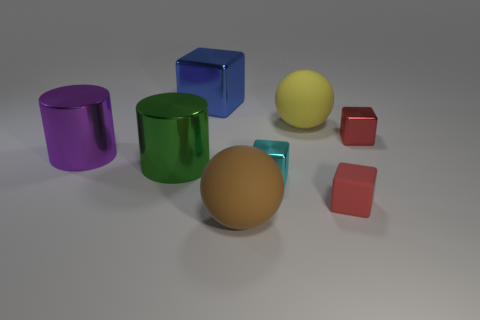Subtract all green cubes. Subtract all yellow cylinders. How many cubes are left? 4 Add 1 small red cubes. How many objects exist? 9 Subtract all cylinders. How many objects are left? 6 Add 4 small yellow rubber things. How many small yellow rubber things exist? 4 Subtract 0 brown cylinders. How many objects are left? 8 Subtract all green cylinders. Subtract all big green metal cylinders. How many objects are left? 6 Add 8 brown rubber spheres. How many brown rubber spheres are left? 9 